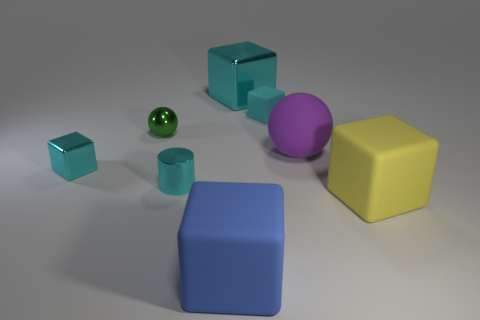What number of tiny objects are either gray rubber objects or blue matte blocks?
Your answer should be very brief. 0. Is the number of small shiny cylinders less than the number of cyan cubes?
Offer a terse response. Yes. The other small metal object that is the same shape as the purple object is what color?
Offer a terse response. Green. Are there more tiny cyan cylinders than small blue shiny balls?
Give a very brief answer. Yes. What number of other things are made of the same material as the tiny cylinder?
Make the answer very short. 3. What shape is the purple object in front of the small block on the right side of the metal cube in front of the green ball?
Keep it short and to the point. Sphere. Are there fewer big rubber things that are to the right of the blue block than objects that are left of the purple object?
Your answer should be very brief. Yes. Is there a big metal block of the same color as the small rubber block?
Your answer should be very brief. Yes. Does the big blue block have the same material as the large cube behind the yellow block?
Your response must be concise. No. There is a cyan thing that is left of the cyan cylinder; is there a rubber sphere that is in front of it?
Offer a very short reply. No. 